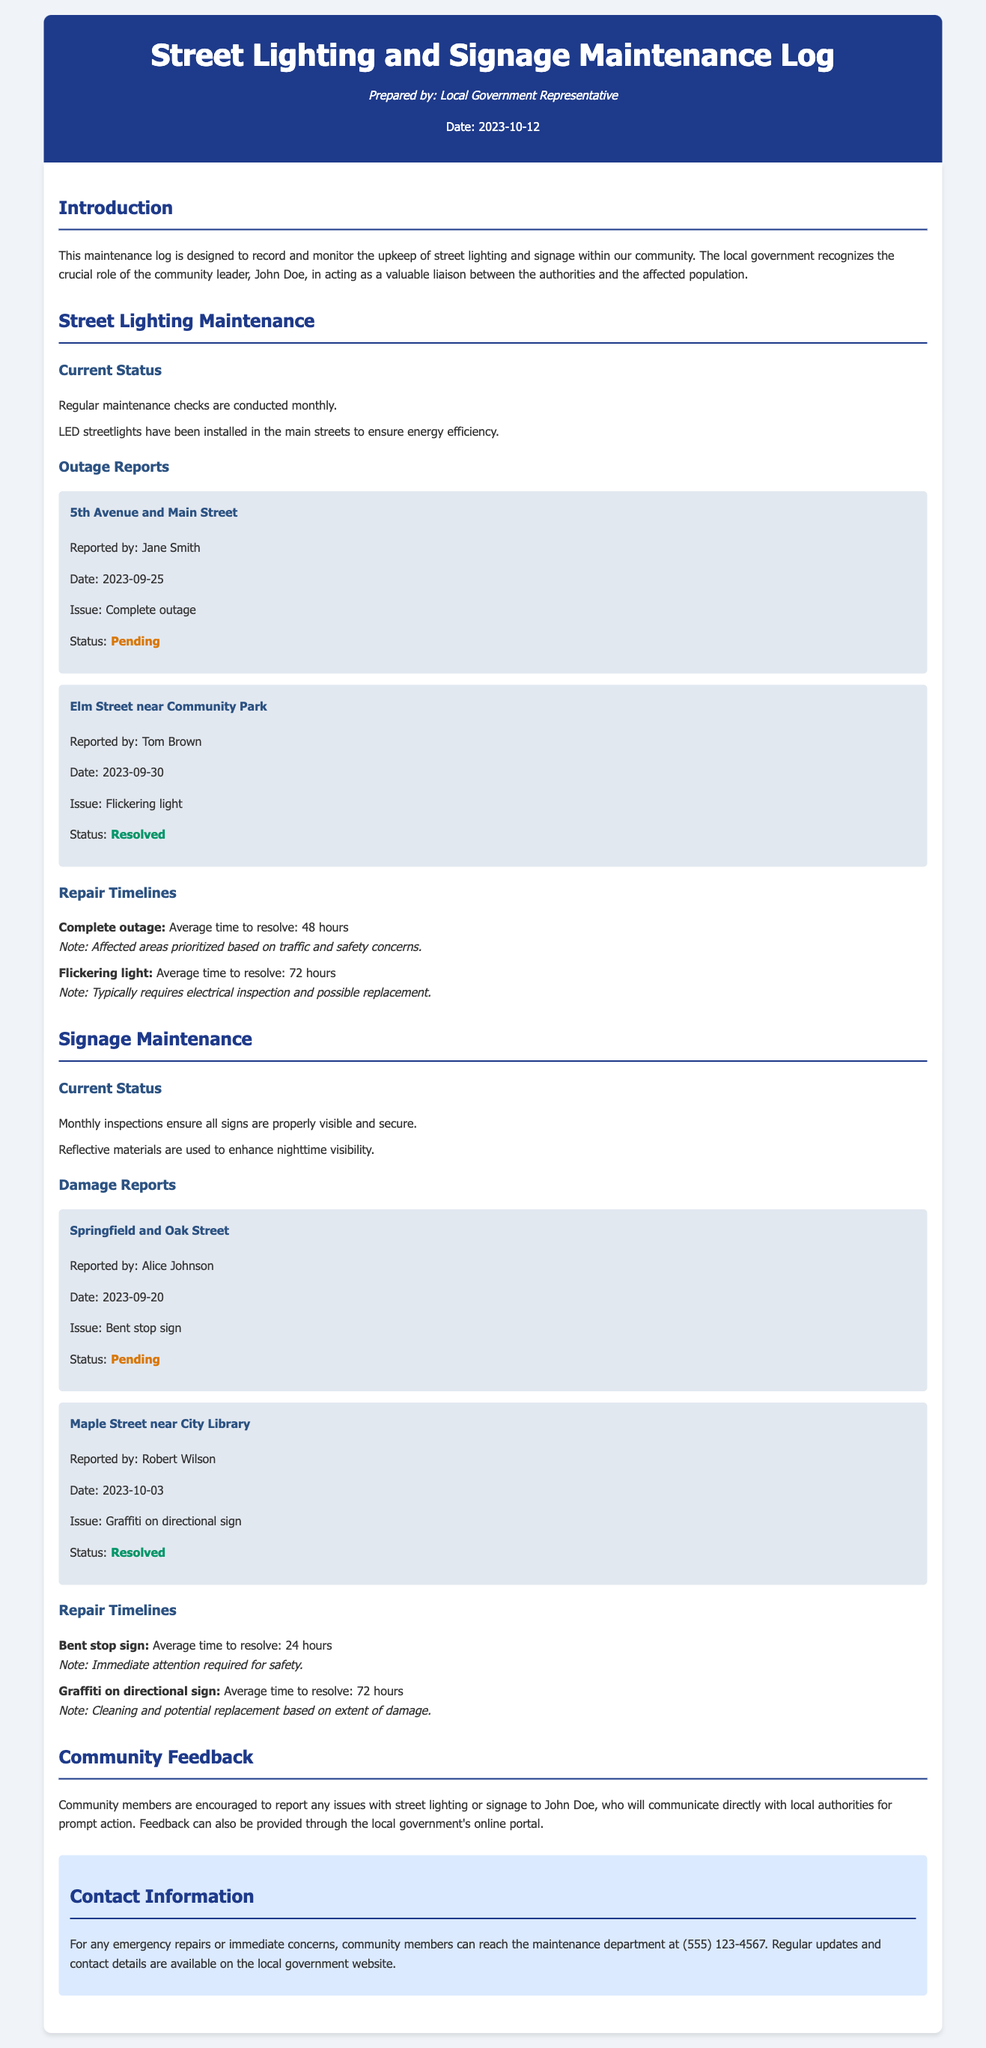What is the title of the document? The title is indicated in the header section of the document.
Answer: Street Lighting and Signage Maintenance Log Who reported the outage at 5th Avenue and Main Street? The report includes the name of the person who reported the outage in the accompanying details.
Answer: Jane Smith What is the current status of the flickering light at Elm Street near Community Park? The status is clearly stated under the outage report for this location.
Answer: Resolved What is the average time to resolve a complete outage? The document provides specific average resolution times for different issues, including complete outages.
Answer: 48 hours Which sign is reported as bent at Springfield and Oak Street? This information is mentioned in the damage reports section of the document.
Answer: Bent stop sign How many days does it typically take to resolve graffiti on a directional sign? The average time for this issue is noted in the repair timelines section.
Answer: 72 hours Why is immediate attention required for a bent stop sign? The document explains the urgency related to safety matters concerning this issue.
Answer: Safety What should community members do to report issues with street lighting or signage? The document specifies the method for reporting issues within the community.
Answer: Contact John Doe 